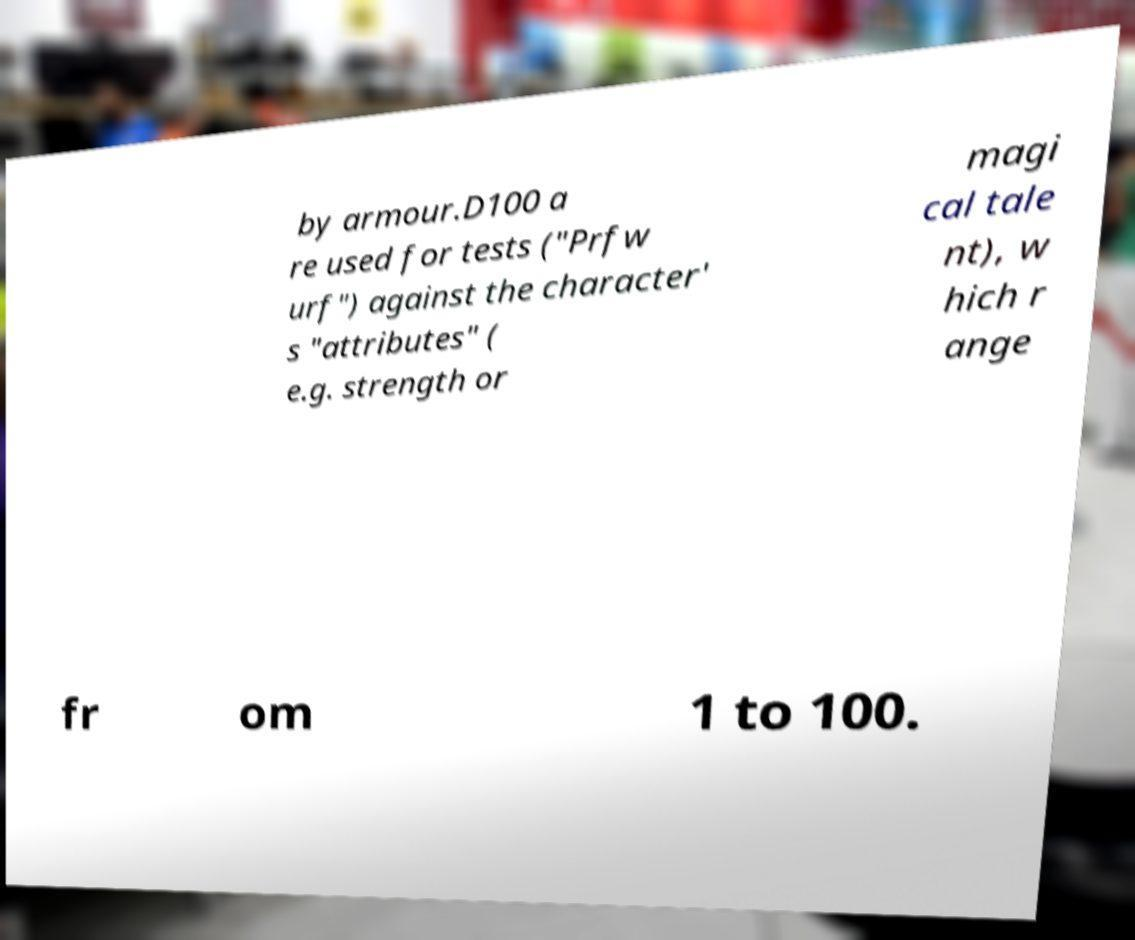Can you read and provide the text displayed in the image?This photo seems to have some interesting text. Can you extract and type it out for me? by armour.D100 a re used for tests ("Prfw urf") against the character' s "attributes" ( e.g. strength or magi cal tale nt), w hich r ange fr om 1 to 100. 